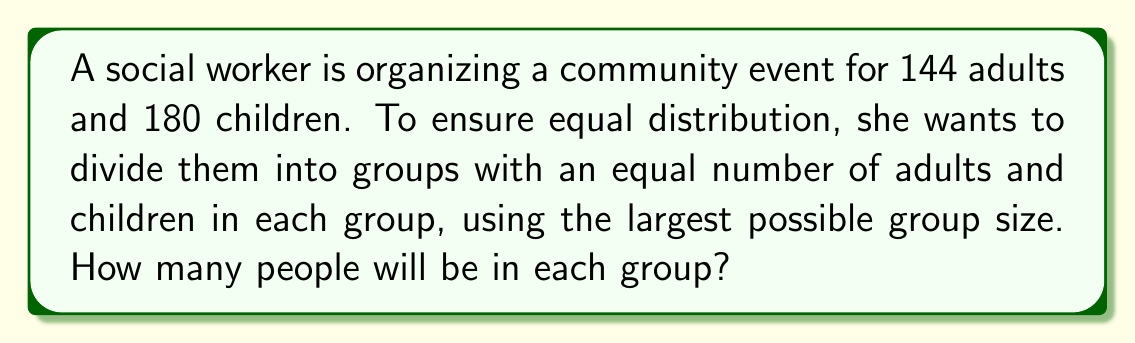Help me with this question. To solve this problem, we need to find the Greatest Common Divisor (GCD) of 144 and 180 using the Euclidean algorithm. This will give us the largest possible group size.

Let's apply the Euclidean algorithm:

1) First, we divide 180 by 144:
   $180 = 1 \times 144 + 36$

2) Now, we divide 144 by 36:
   $144 = 4 \times 36 + 0$

3) The process stops here because we've reached a remainder of 0.

4) The last non-zero remainder is 36, so this is our GCD.

Therefore, the GCD of 144 and 180 is 36.

This means we can form groups of 36 people each. In each group, there will be:

- Adults: $144 \div 36 = 4$ adults per group
- Children: $180 \div 36 = 5$ children per group

The total number of people in each group is $4 + 5 = 9$.
Answer: 9 people 